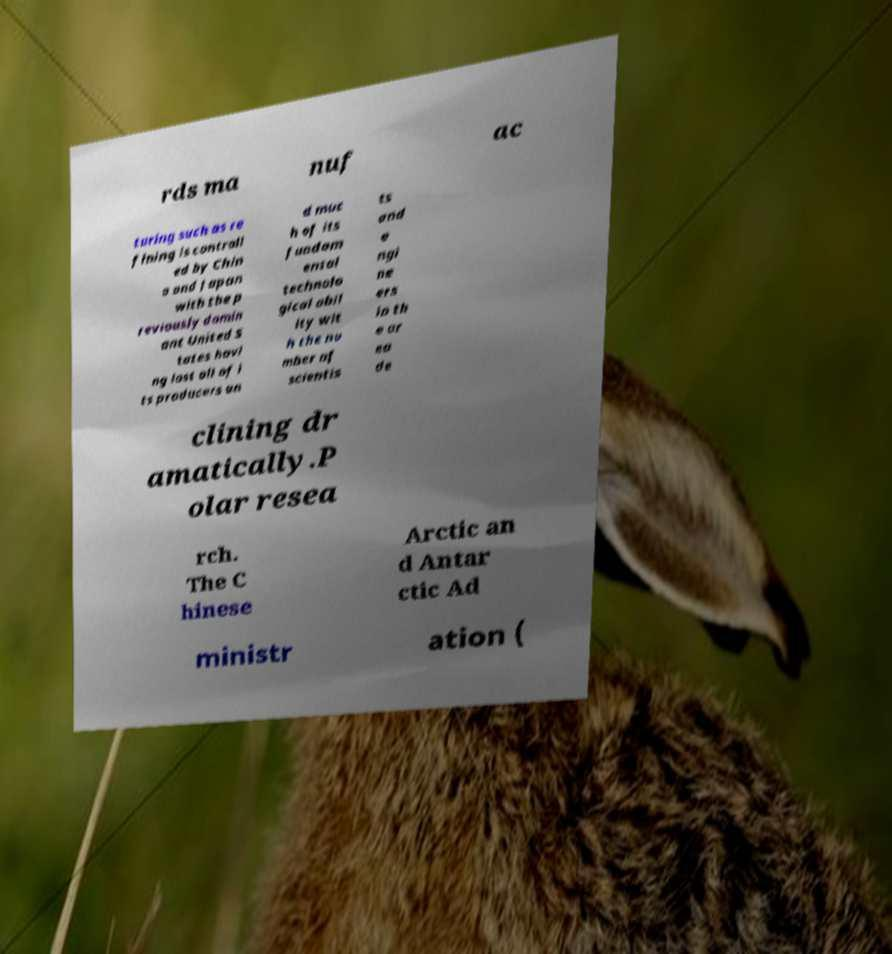I need the written content from this picture converted into text. Can you do that? rds ma nuf ac turing such as re fining is controll ed by Chin a and Japan with the p reviously domin ant United S tates havi ng lost all of i ts producers an d muc h of its fundam ental technolo gical abil ity wit h the nu mber of scientis ts and e ngi ne ers in th e ar ea de clining dr amatically.P olar resea rch. The C hinese Arctic an d Antar ctic Ad ministr ation ( 